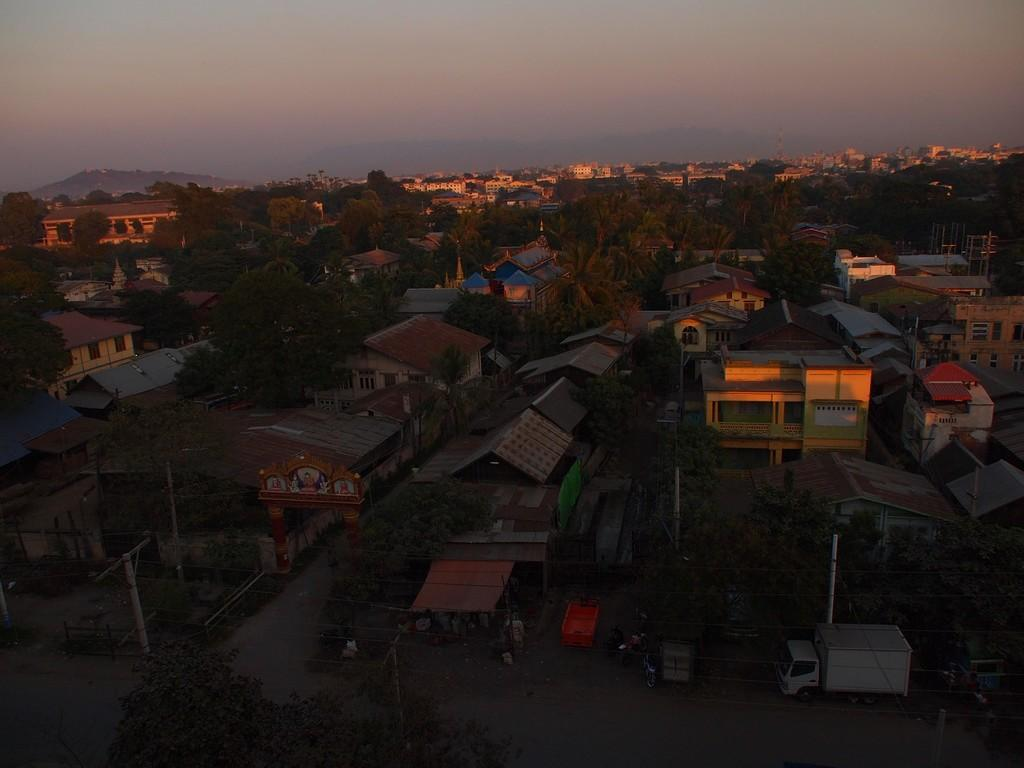What is the perspective of the image? The image is taken from a top angle. What type of structures can be seen in the image? There are houses in the image. What natural elements are present in the image? There are trees and mountains in the image. What man-made structures can be seen in the image? There are roads in the image. What part of the natural environment is visible in the image? The sky is visible in the image. Can you see any cows kicking a soccer ball in the image? There are no cows or soccer balls present in the image. 